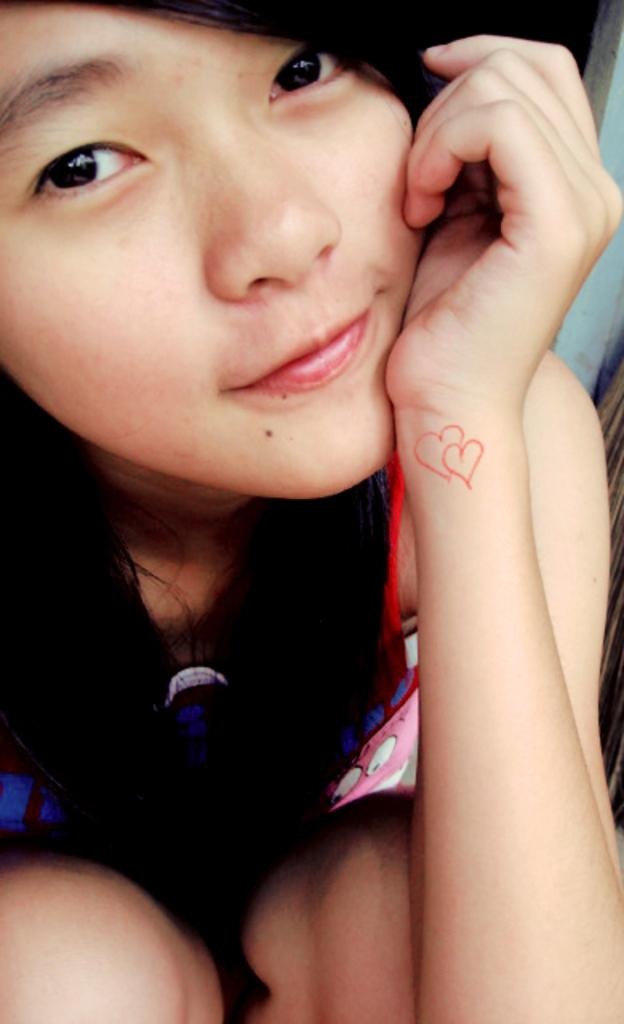Who is present in the image? There is a girl in the image. What is the girl wearing? The girl is wearing clothes. What type of trees are present in the image? There are no trees present in the image; it only features a girl wearing clothes. 